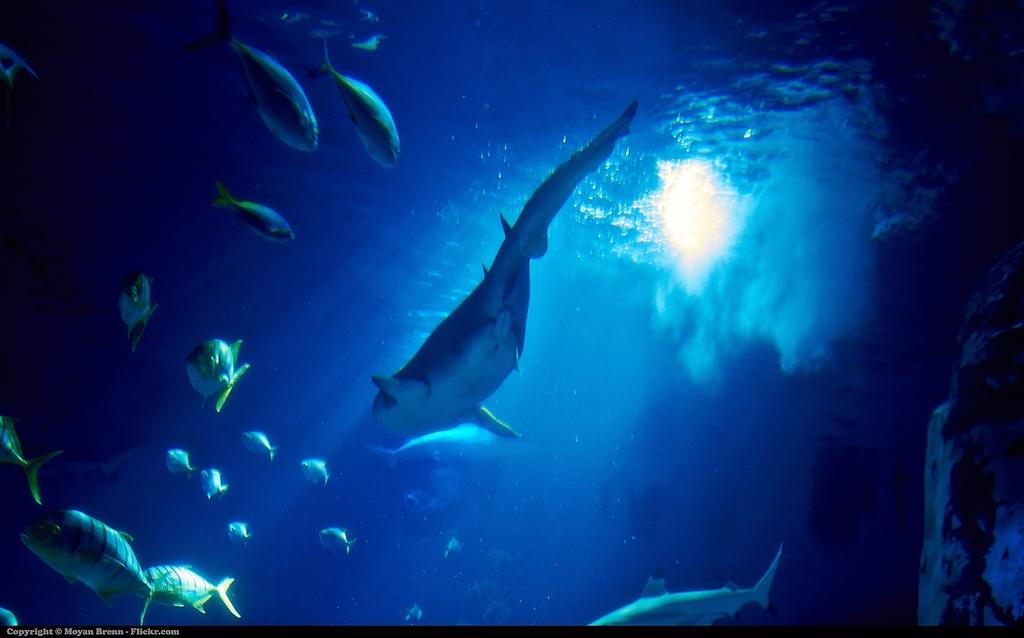What is the main subject in the center of the image? There is a fish in the center of the image. Where is the fish located? The fish is underwater. Are there any other fish visible in the image? Yes, there are fishes on the left side of the image. What can be seen in the background of the image? There is water visible in the background of the image. What type of insurance is required for the fish in the image? There is no mention of insurance in the image, as it features fish underwater. 